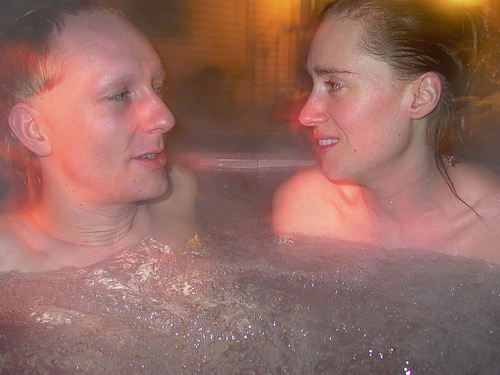<image>
Is there a water under the man? Yes. The water is positioned underneath the man, with the man above it in the vertical space. Is the man next to the lady? Yes. The man is positioned adjacent to the lady, located nearby in the same general area. 